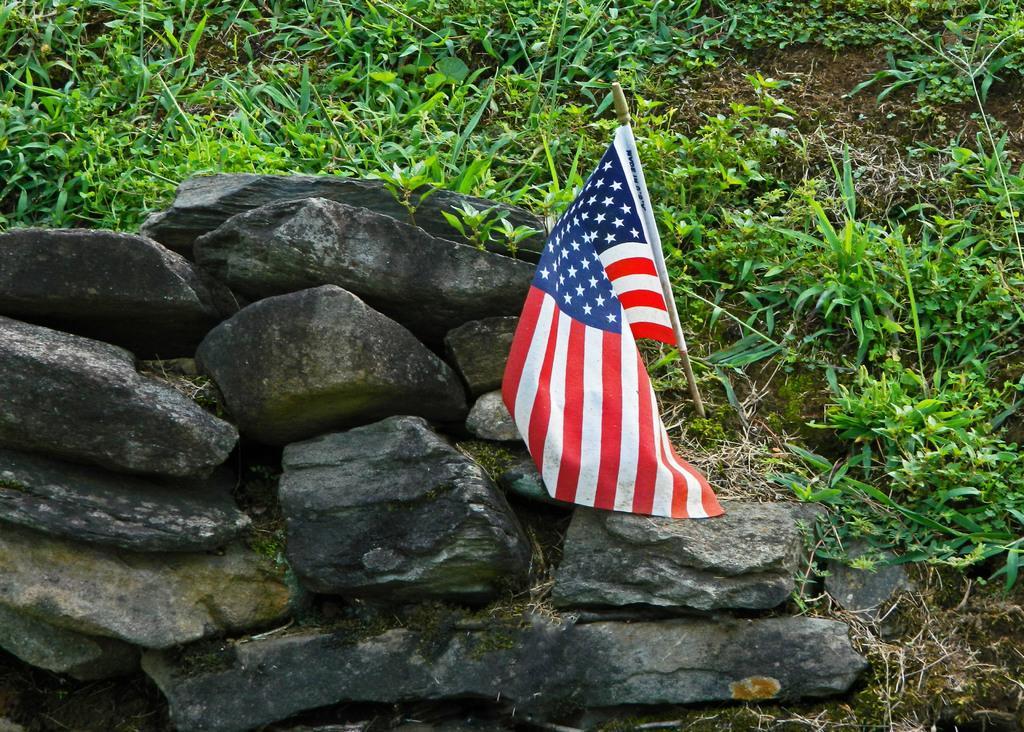Please provide a concise description of this image. In this picture we can see rocks and a flag in the front, in the background there are some plants. 